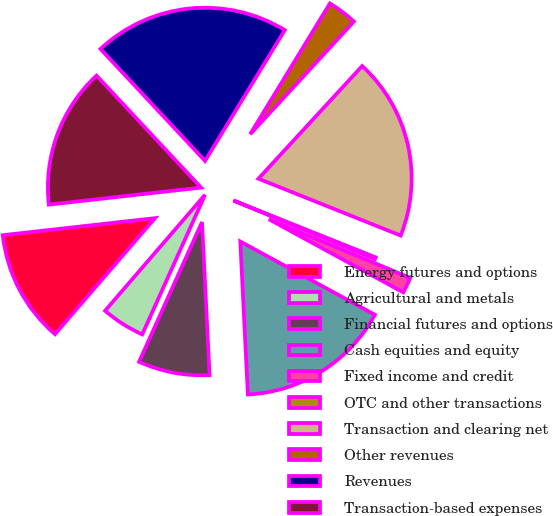Convert chart. <chart><loc_0><loc_0><loc_500><loc_500><pie_chart><fcel>Energy futures and options<fcel>Agricultural and metals<fcel>Financial futures and options<fcel>Cash equities and equity<fcel>Fixed income and credit<fcel>OTC and other transactions<fcel>Transaction and clearing net<fcel>Other revenues<fcel>Revenues<fcel>Transaction-based expenses<nl><fcel>11.9%<fcel>4.59%<fcel>7.52%<fcel>16.28%<fcel>1.67%<fcel>0.21%<fcel>19.21%<fcel>3.13%<fcel>20.67%<fcel>14.82%<nl></chart> 